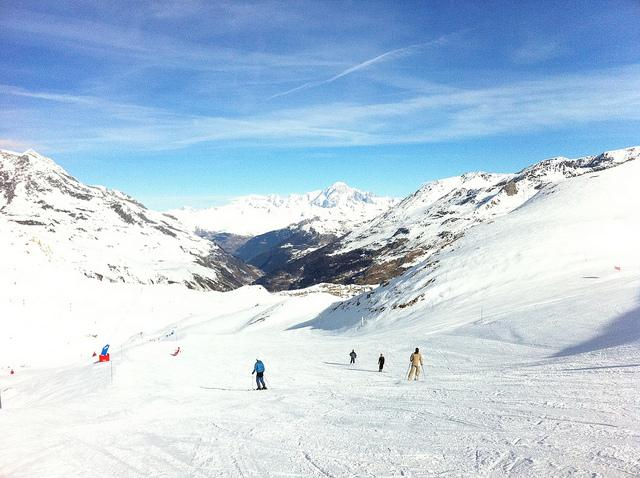What type of sport is this? skiing 